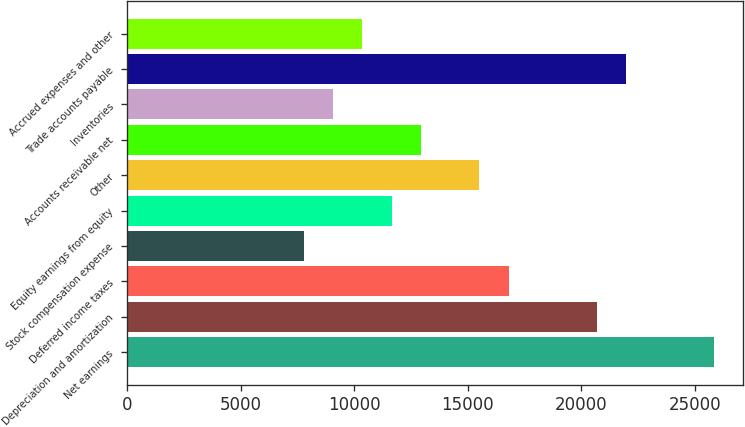Convert chart to OTSL. <chart><loc_0><loc_0><loc_500><loc_500><bar_chart><fcel>Net earnings<fcel>Depreciation and amortization<fcel>Deferred income taxes<fcel>Stock compensation expense<fcel>Equity earnings from equity<fcel>Other<fcel>Accounts receivable net<fcel>Inventories<fcel>Trade accounts payable<fcel>Accrued expenses and other<nl><fcel>25842<fcel>20678.8<fcel>16806.4<fcel>7770.8<fcel>11643.2<fcel>15515.6<fcel>12934<fcel>9061.6<fcel>21969.6<fcel>10352.4<nl></chart> 